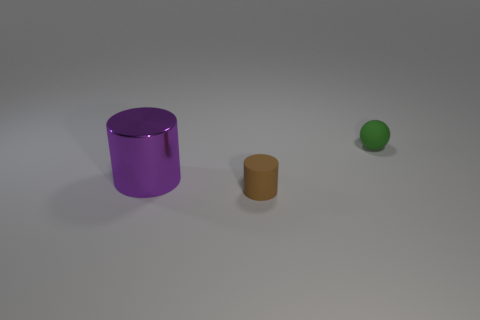There is a brown cylinder; does it have the same size as the object on the right side of the brown matte object?
Offer a very short reply. Yes. There is a thing that is both left of the tiny green matte object and behind the brown matte thing; what size is it?
Keep it short and to the point. Large. Are there any tiny matte objects of the same color as the shiny thing?
Your answer should be compact. No. There is a rubber thing in front of the small thing that is on the right side of the brown cylinder; what color is it?
Your answer should be very brief. Brown. Is the number of brown objects in front of the tiny brown rubber cylinder less than the number of spheres right of the green sphere?
Make the answer very short. No. Is the metal cylinder the same size as the green sphere?
Provide a short and direct response. No. The thing that is on the right side of the big shiny cylinder and behind the brown thing has what shape?
Offer a terse response. Sphere. What number of large purple cylinders have the same material as the small cylinder?
Provide a short and direct response. 0. There is a matte thing that is behind the tiny brown object; how many things are on the left side of it?
Keep it short and to the point. 2. What shape is the thing that is behind the cylinder that is behind the rubber object that is left of the green thing?
Offer a very short reply. Sphere. 